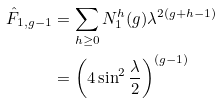<formula> <loc_0><loc_0><loc_500><loc_500>\hat { F } _ { 1 , g - 1 } & = \sum _ { h \geq 0 } N _ { 1 } ^ { h } ( g ) \lambda ^ { 2 ( g + h - 1 ) } \\ & = \left ( 4 \sin ^ { 2 } \frac { \lambda } { 2 } \right ) ^ { ( g - 1 ) }</formula> 